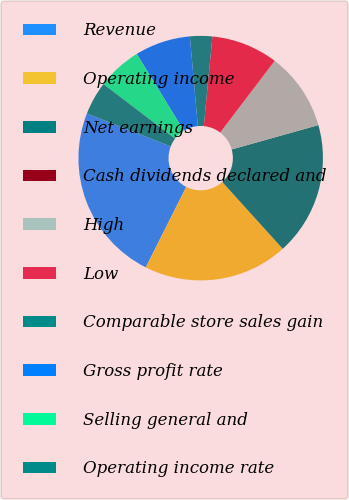Convert chart to OTSL. <chart><loc_0><loc_0><loc_500><loc_500><pie_chart><fcel>Revenue<fcel>Operating income<fcel>Net earnings<fcel>Cash dividends declared and<fcel>High<fcel>Low<fcel>Comparable store sales gain<fcel>Gross profit rate<fcel>Selling general and<fcel>Operating income rate<nl><fcel>23.53%<fcel>19.12%<fcel>17.65%<fcel>0.0%<fcel>10.29%<fcel>8.82%<fcel>2.94%<fcel>7.35%<fcel>5.88%<fcel>4.41%<nl></chart> 